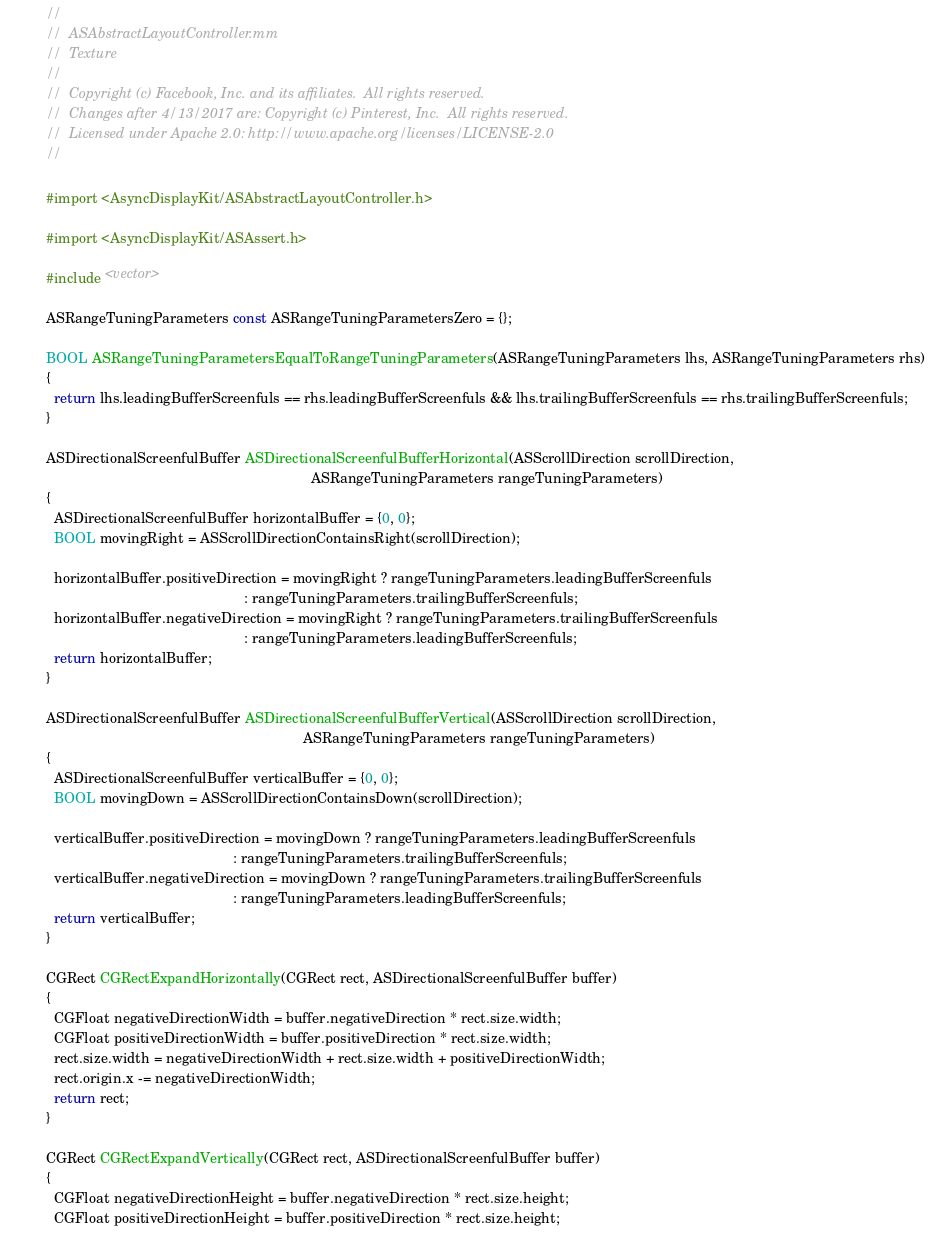<code> <loc_0><loc_0><loc_500><loc_500><_ObjectiveC_>//
//  ASAbstractLayoutController.mm
//  Texture
//
//  Copyright (c) Facebook, Inc. and its affiliates.  All rights reserved.
//  Changes after 4/13/2017 are: Copyright (c) Pinterest, Inc.  All rights reserved.
//  Licensed under Apache 2.0: http://www.apache.org/licenses/LICENSE-2.0
//

#import <AsyncDisplayKit/ASAbstractLayoutController.h>

#import <AsyncDisplayKit/ASAssert.h>

#include <vector>

ASRangeTuningParameters const ASRangeTuningParametersZero = {};

BOOL ASRangeTuningParametersEqualToRangeTuningParameters(ASRangeTuningParameters lhs, ASRangeTuningParameters rhs)
{
  return lhs.leadingBufferScreenfuls == rhs.leadingBufferScreenfuls && lhs.trailingBufferScreenfuls == rhs.trailingBufferScreenfuls;
}

ASDirectionalScreenfulBuffer ASDirectionalScreenfulBufferHorizontal(ASScrollDirection scrollDirection,
                                                                    ASRangeTuningParameters rangeTuningParameters)
{
  ASDirectionalScreenfulBuffer horizontalBuffer = {0, 0};
  BOOL movingRight = ASScrollDirectionContainsRight(scrollDirection);
  
  horizontalBuffer.positiveDirection = movingRight ? rangeTuningParameters.leadingBufferScreenfuls
                                                   : rangeTuningParameters.trailingBufferScreenfuls;
  horizontalBuffer.negativeDirection = movingRight ? rangeTuningParameters.trailingBufferScreenfuls
                                                   : rangeTuningParameters.leadingBufferScreenfuls;
  return horizontalBuffer;
}

ASDirectionalScreenfulBuffer ASDirectionalScreenfulBufferVertical(ASScrollDirection scrollDirection,
                                                                  ASRangeTuningParameters rangeTuningParameters)
{
  ASDirectionalScreenfulBuffer verticalBuffer = {0, 0};
  BOOL movingDown = ASScrollDirectionContainsDown(scrollDirection);
  
  verticalBuffer.positiveDirection = movingDown ? rangeTuningParameters.leadingBufferScreenfuls
                                                : rangeTuningParameters.trailingBufferScreenfuls;
  verticalBuffer.negativeDirection = movingDown ? rangeTuningParameters.trailingBufferScreenfuls
                                                : rangeTuningParameters.leadingBufferScreenfuls;
  return verticalBuffer;
}

CGRect CGRectExpandHorizontally(CGRect rect, ASDirectionalScreenfulBuffer buffer)
{
  CGFloat negativeDirectionWidth = buffer.negativeDirection * rect.size.width;
  CGFloat positiveDirectionWidth = buffer.positiveDirection * rect.size.width;
  rect.size.width = negativeDirectionWidth + rect.size.width + positiveDirectionWidth;
  rect.origin.x -= negativeDirectionWidth;
  return rect;
}

CGRect CGRectExpandVertically(CGRect rect, ASDirectionalScreenfulBuffer buffer)
{
  CGFloat negativeDirectionHeight = buffer.negativeDirection * rect.size.height;
  CGFloat positiveDirectionHeight = buffer.positiveDirection * rect.size.height;</code> 